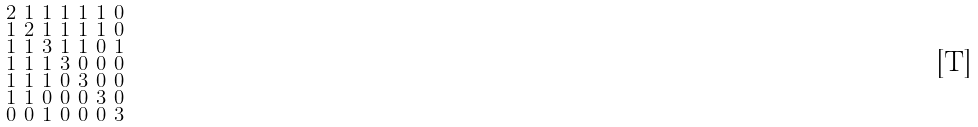Convert formula to latex. <formula><loc_0><loc_0><loc_500><loc_500>\begin{smallmatrix} 2 & 1 & 1 & 1 & 1 & 1 & 0 \\ 1 & 2 & 1 & 1 & 1 & 1 & 0 \\ 1 & 1 & 3 & 1 & 1 & 0 & 1 \\ 1 & 1 & 1 & 3 & 0 & 0 & 0 \\ 1 & 1 & 1 & 0 & 3 & 0 & 0 \\ 1 & 1 & 0 & 0 & 0 & 3 & 0 \\ 0 & 0 & 1 & 0 & 0 & 0 & 3 \end{smallmatrix}</formula> 